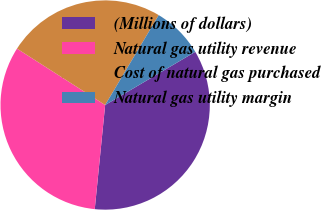Convert chart to OTSL. <chart><loc_0><loc_0><loc_500><loc_500><pie_chart><fcel>(Millions of dollars)<fcel>Natural gas utility revenue<fcel>Cost of natural gas purchased<fcel>Natural gas utility margin<nl><fcel>35.07%<fcel>32.47%<fcel>24.5%<fcel>7.96%<nl></chart> 